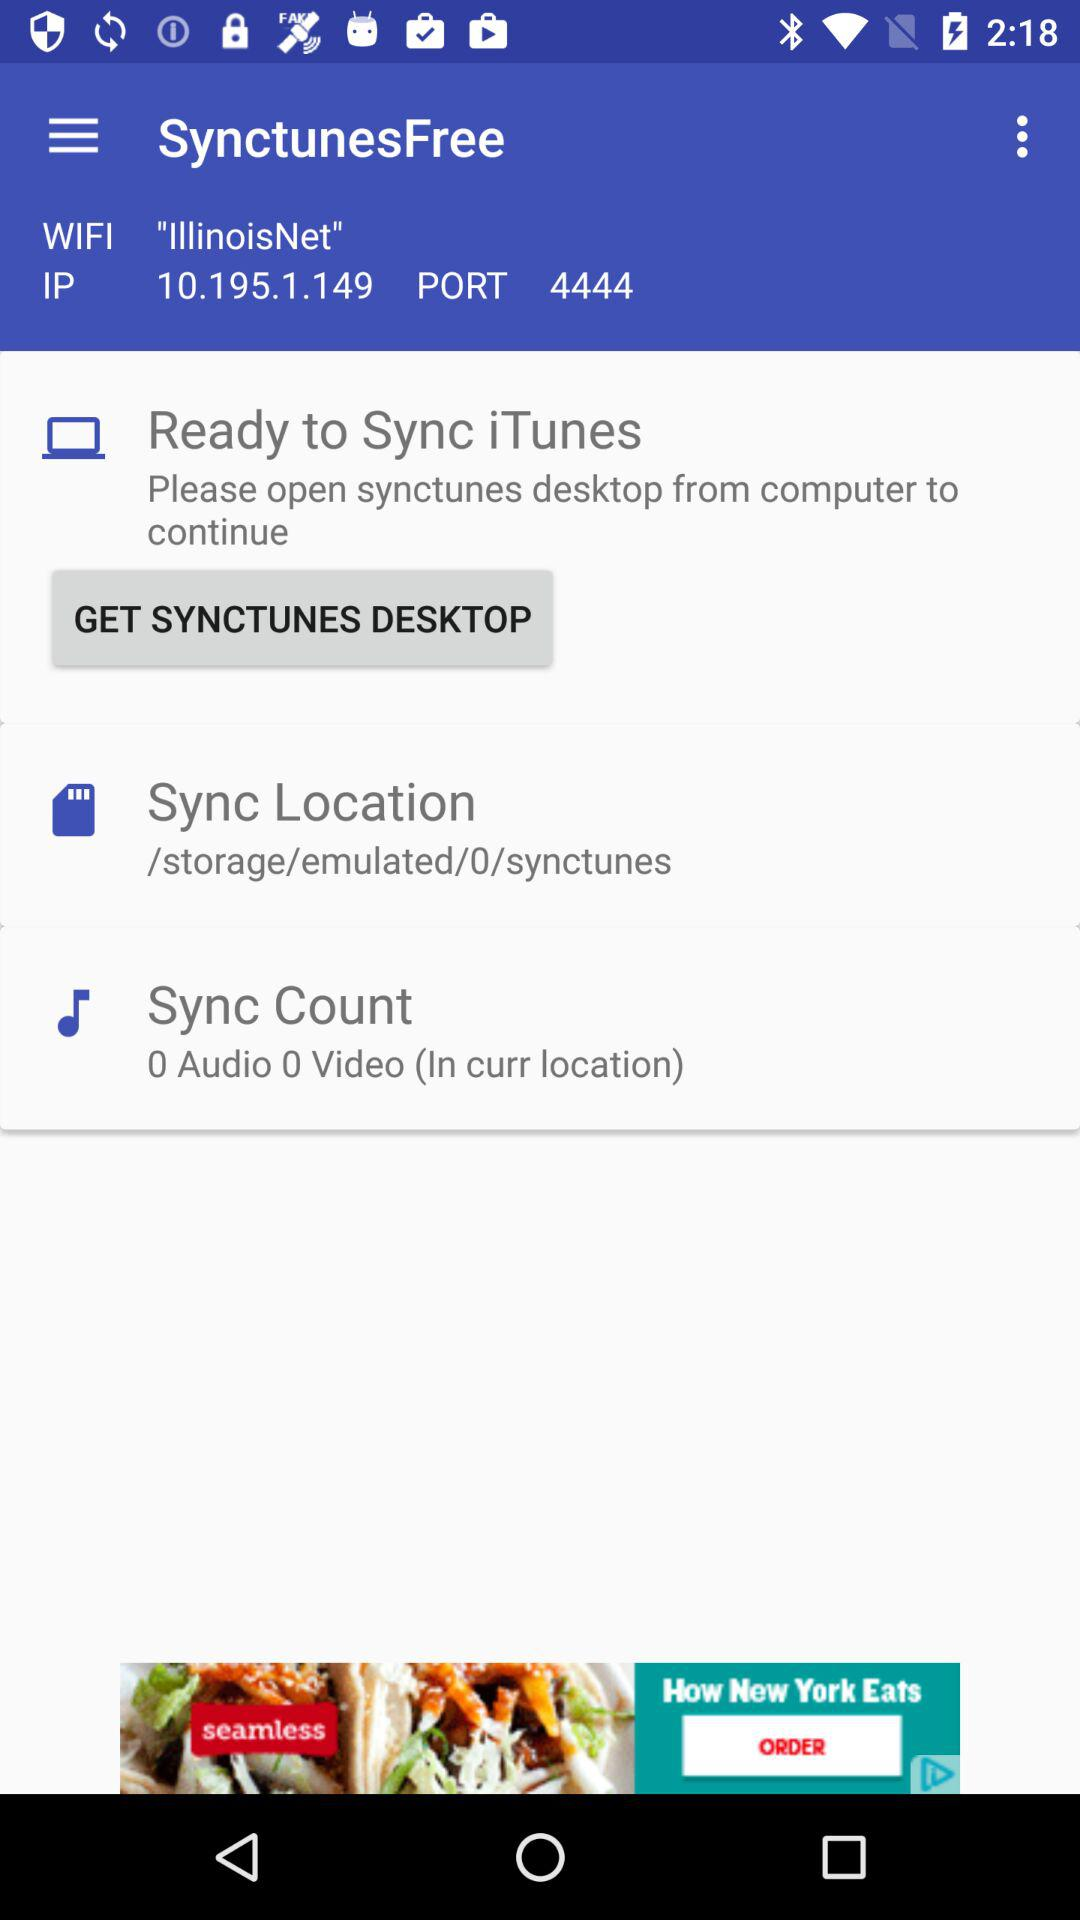What is the port number? The port number is 4444. 